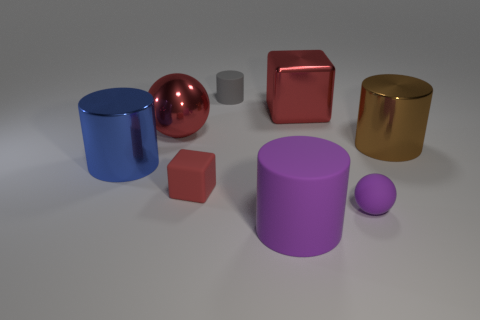Do the large sphere and the rubber ball have the same color?
Your response must be concise. No. What number of metal spheres are on the right side of the metallic object right of the small object in front of the tiny red matte thing?
Offer a very short reply. 0. There is a big purple thing that is made of the same material as the purple ball; what shape is it?
Provide a short and direct response. Cylinder. There is a tiny object on the right side of the matte cylinder that is in front of the rubber thing behind the large sphere; what is its material?
Your response must be concise. Rubber. What number of objects are cylinders that are in front of the small gray rubber object or purple matte spheres?
Make the answer very short. 4. How many other things are the same shape as the tiny red rubber object?
Keep it short and to the point. 1. Is the number of large red shiny cubes right of the big brown object greater than the number of blocks?
Your response must be concise. No. There is a purple thing that is the same shape as the small gray rubber thing; what is its size?
Offer a very short reply. Large. Is there anything else that is made of the same material as the small gray cylinder?
Your answer should be compact. Yes. What is the shape of the big rubber thing?
Your answer should be very brief. Cylinder. 